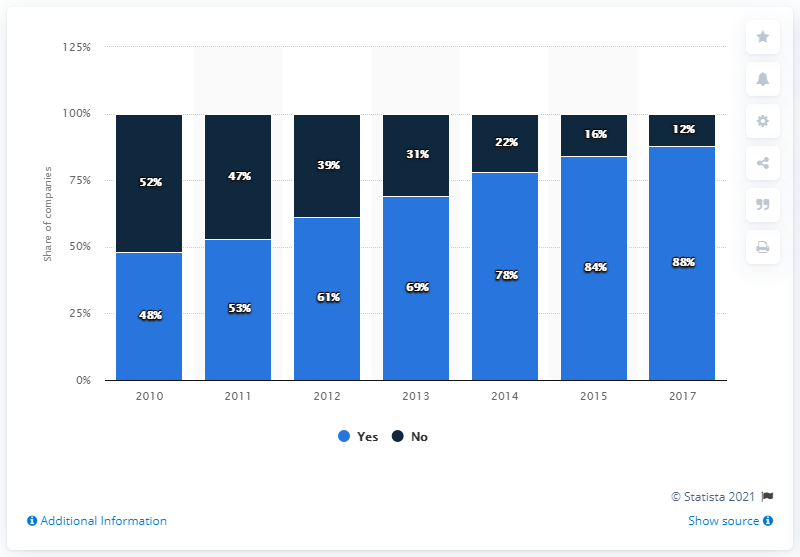Draw attention to some important aspects in this diagram. The average score for those who have not used the targeted services is 31.29. The more common answer is 'Yes.' 